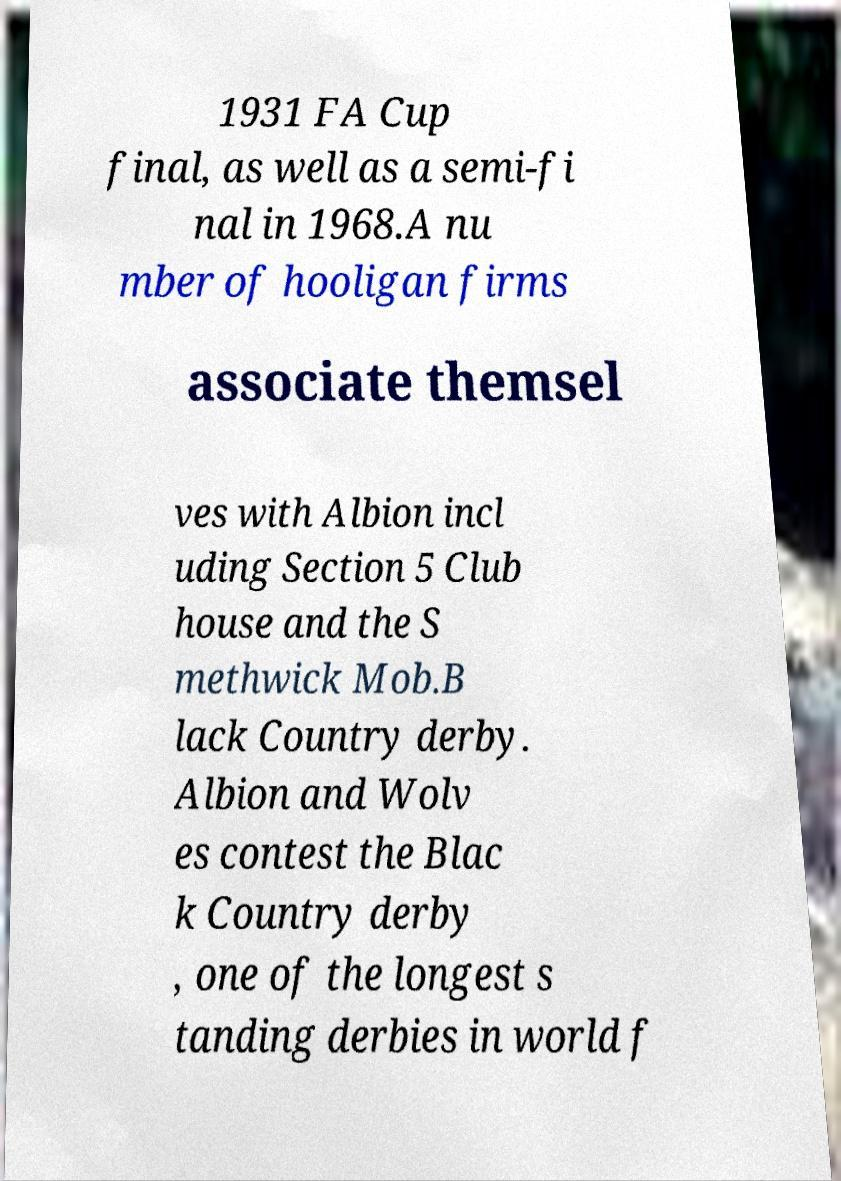What messages or text are displayed in this image? I need them in a readable, typed format. 1931 FA Cup final, as well as a semi-fi nal in 1968.A nu mber of hooligan firms associate themsel ves with Albion incl uding Section 5 Club house and the S methwick Mob.B lack Country derby. Albion and Wolv es contest the Blac k Country derby , one of the longest s tanding derbies in world f 